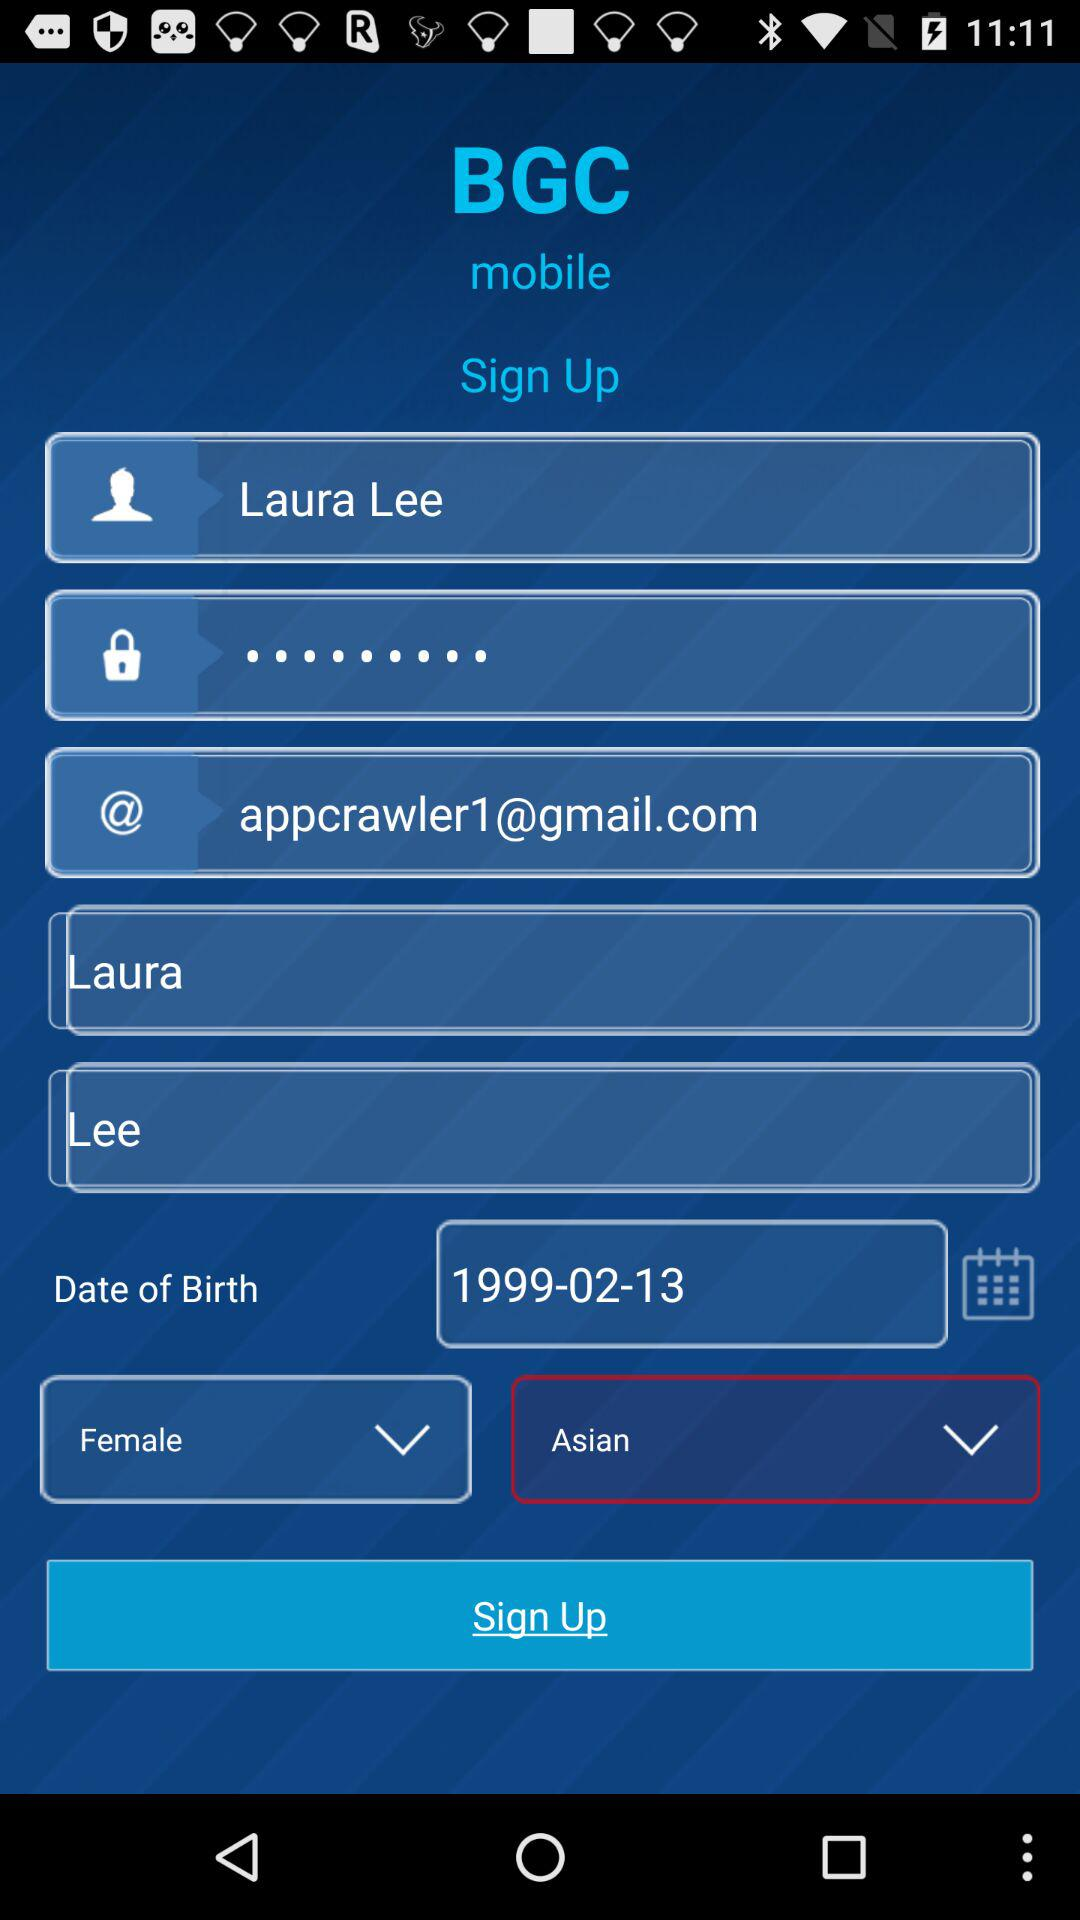What is the name of the application? The name of the application is "BGC mobile". 